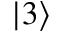Convert formula to latex. <formula><loc_0><loc_0><loc_500><loc_500>| 3 \rangle</formula> 